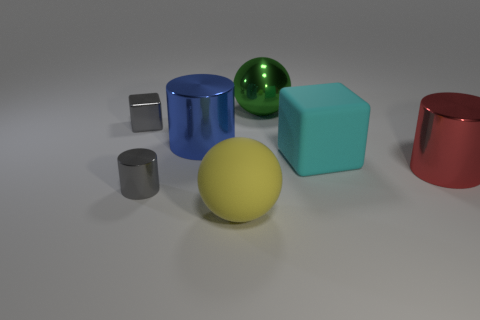Add 2 big metal objects. How many objects exist? 9 Subtract all cubes. How many objects are left? 5 Add 5 gray objects. How many gray objects exist? 7 Subtract 1 green spheres. How many objects are left? 6 Subtract all gray metal cylinders. Subtract all big blue cylinders. How many objects are left? 5 Add 6 blue metal things. How many blue metal things are left? 7 